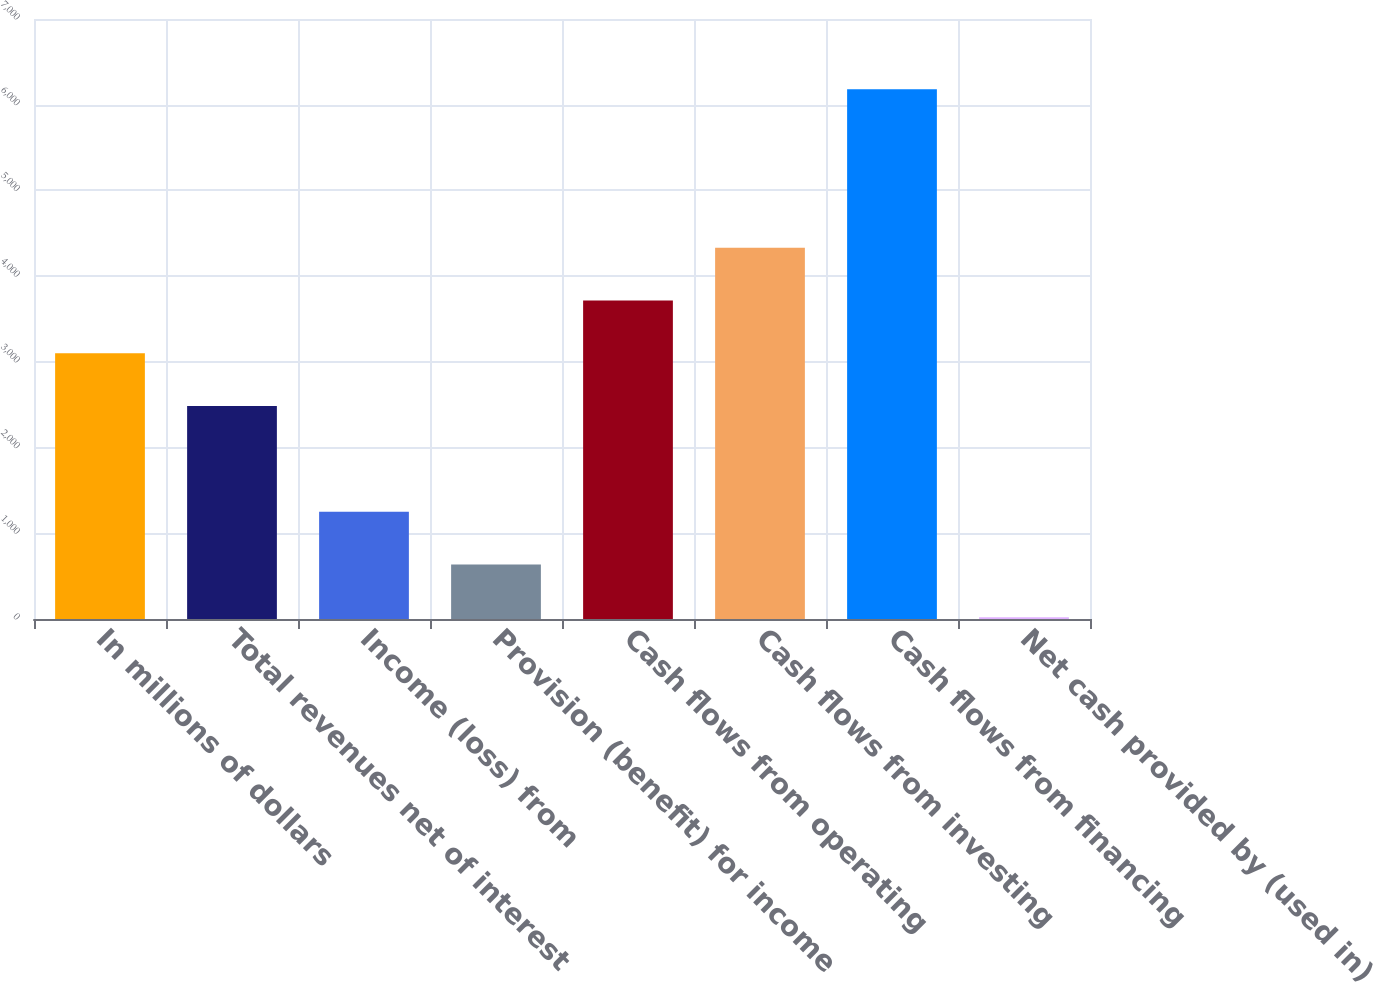<chart> <loc_0><loc_0><loc_500><loc_500><bar_chart><fcel>In millions of dollars<fcel>Total revenues net of interest<fcel>Income (loss) from<fcel>Provision (benefit) for income<fcel>Cash flows from operating<fcel>Cash flows from investing<fcel>Cash flows from financing<fcel>Net cash provided by (used in)<nl><fcel>3099.5<fcel>2483.6<fcel>1251.8<fcel>635.9<fcel>3715.4<fcel>4331.3<fcel>6179<fcel>20<nl></chart> 